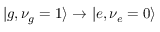Convert formula to latex. <formula><loc_0><loc_0><loc_500><loc_500>| g , \nu _ { g } = 1 \rangle \rightarrow | e , \nu _ { e } = 0 \rangle</formula> 